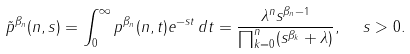<formula> <loc_0><loc_0><loc_500><loc_500>\tilde { p } ^ { \beta _ { n } } ( n , s ) = \int _ { 0 } ^ { \infty } p ^ { \beta _ { n } } ( n , t ) e ^ { - s t } \, d t = \frac { \lambda ^ { n } s ^ { \beta _ { n } - 1 } } { \prod _ { k = 0 } ^ { n } ( s ^ { \beta _ { k } } + \lambda ) } , \ \ s > 0 .</formula> 